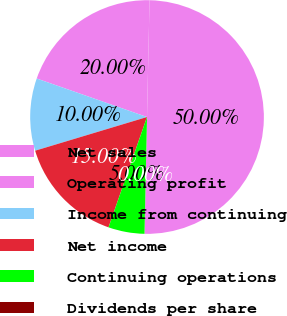Convert chart. <chart><loc_0><loc_0><loc_500><loc_500><pie_chart><fcel>Net sales<fcel>Operating profit<fcel>Income from continuing<fcel>Net income<fcel>Continuing operations<fcel>Dividends per share<nl><fcel>50.0%<fcel>20.0%<fcel>10.0%<fcel>15.0%<fcel>5.0%<fcel>0.0%<nl></chart> 